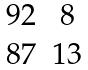Convert formula to latex. <formula><loc_0><loc_0><loc_500><loc_500>\begin{matrix} 9 2 & 8 \\ 8 7 & 1 3 \end{matrix}</formula> 